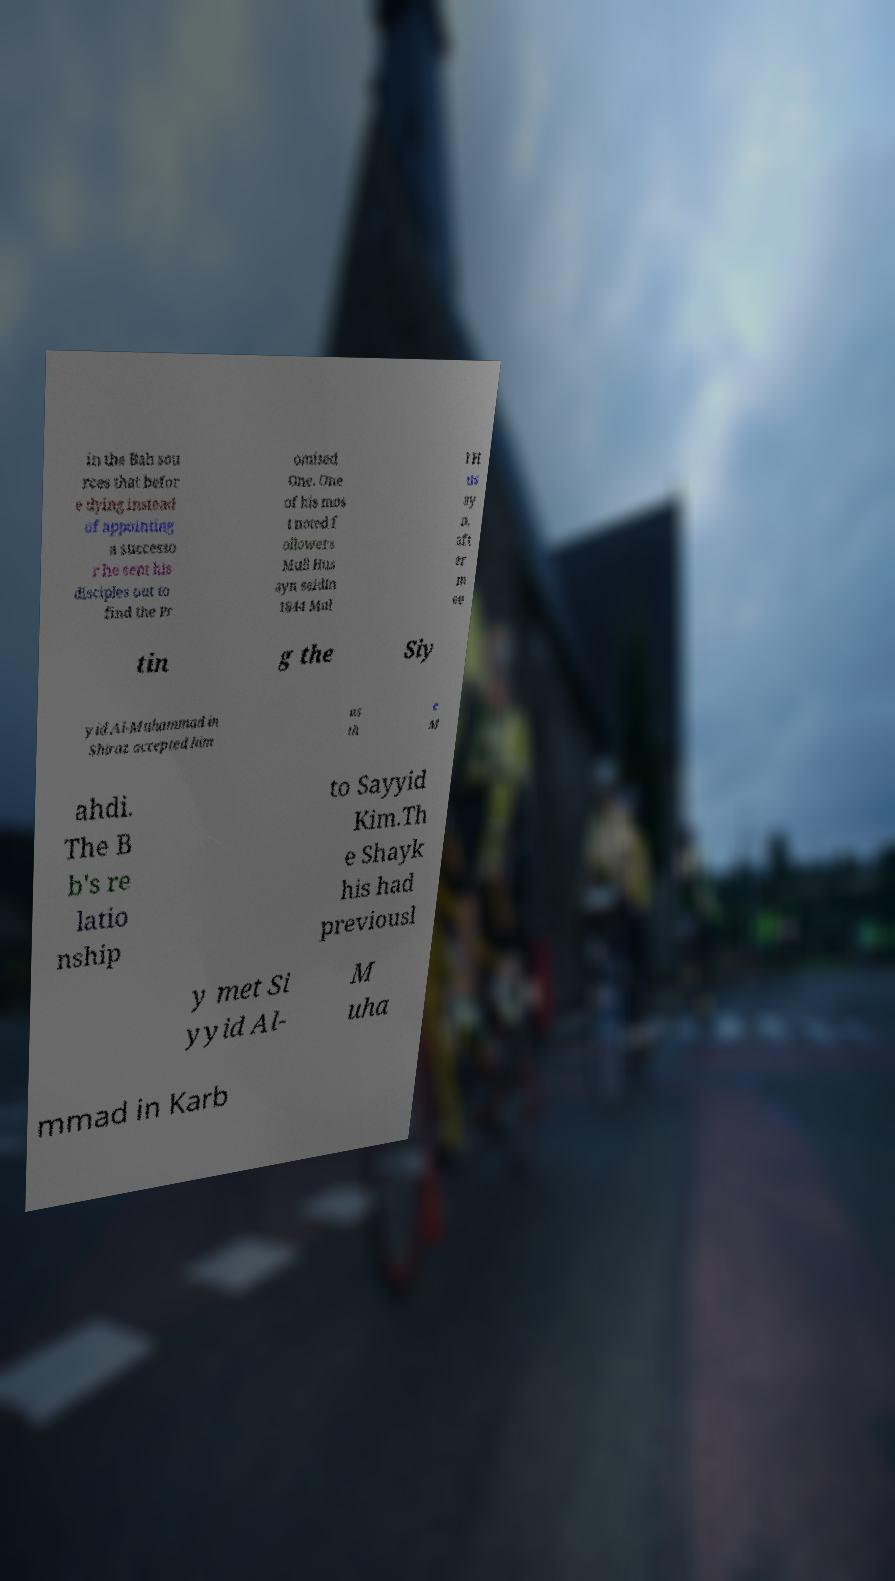Can you read and provide the text displayed in the image?This photo seems to have some interesting text. Can you extract and type it out for me? in the Bah sou rces that befor e dying instead of appointing a successo r he sent his disciples out to find the Pr omised One. One of his mos t noted f ollowers Mull Hus ayn saidIn 1844 Mul l H us ay n, aft er m ee tin g the Siy yid Al-Muhammad in Shiraz accepted him as th e M ahdi. The B b's re latio nship to Sayyid Kim.Th e Shayk his had previousl y met Si yyid Al- M uha mmad in Karb 